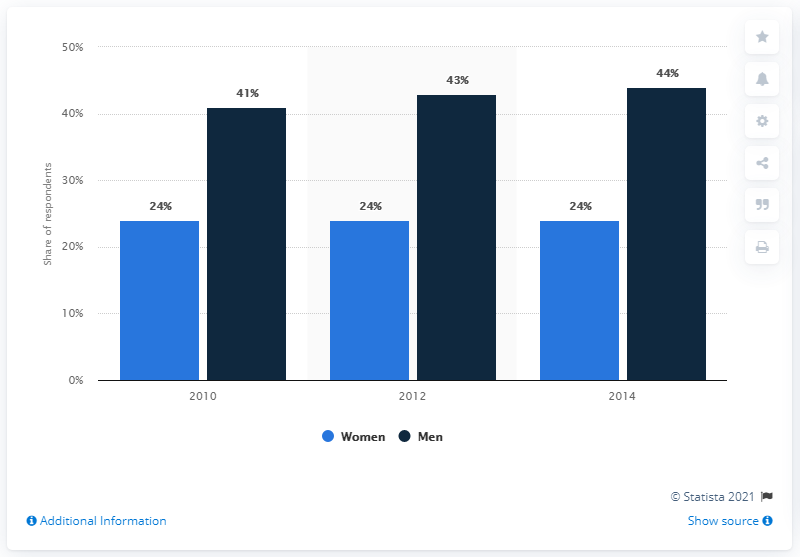Outline some significant characteristics in this image. In 2014, it was found that 44% of men were going to the pub weekly. Approximately 24% of women visited the pub at least once a week between 2010 and 2014. 